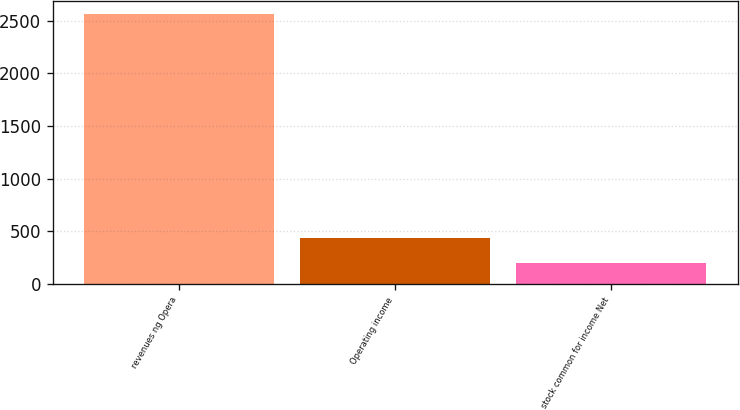Convert chart. <chart><loc_0><loc_0><loc_500><loc_500><bar_chart><fcel>revenues ng Opera<fcel>Operating income<fcel>stock common for income Net<nl><fcel>2562<fcel>435.3<fcel>199<nl></chart> 